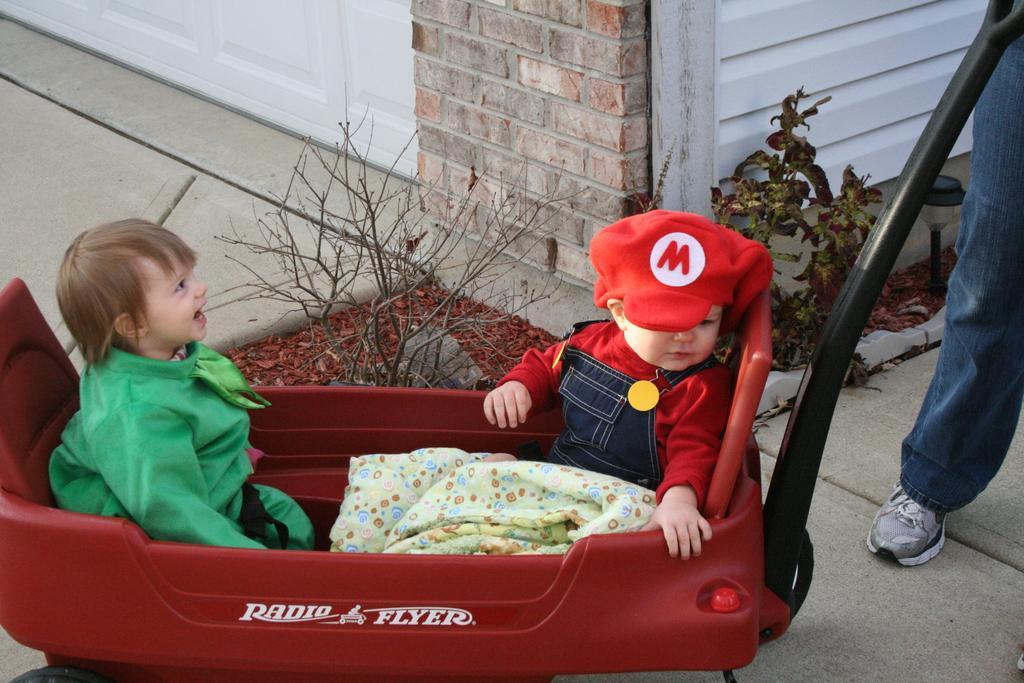Could you give a brief overview of what you see in this image? In this image two kids are sitting in a trolley, near the trolley there is a men, behind the trolley there are plants and a wall. 